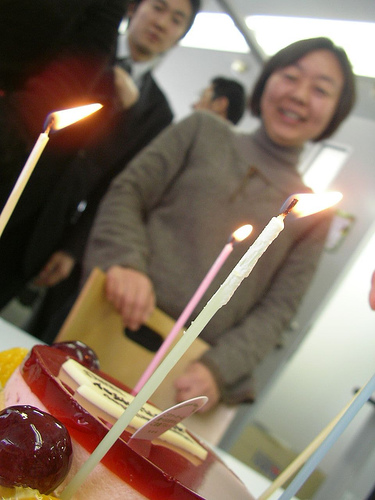Is there anything unique about the way the candles are placed on the cake? Yes, the candles are placed irregularly and at varying heights, which adds a casual and perhaps personal touch to the celebration, as opposed to a more uniform and traditional placement. 